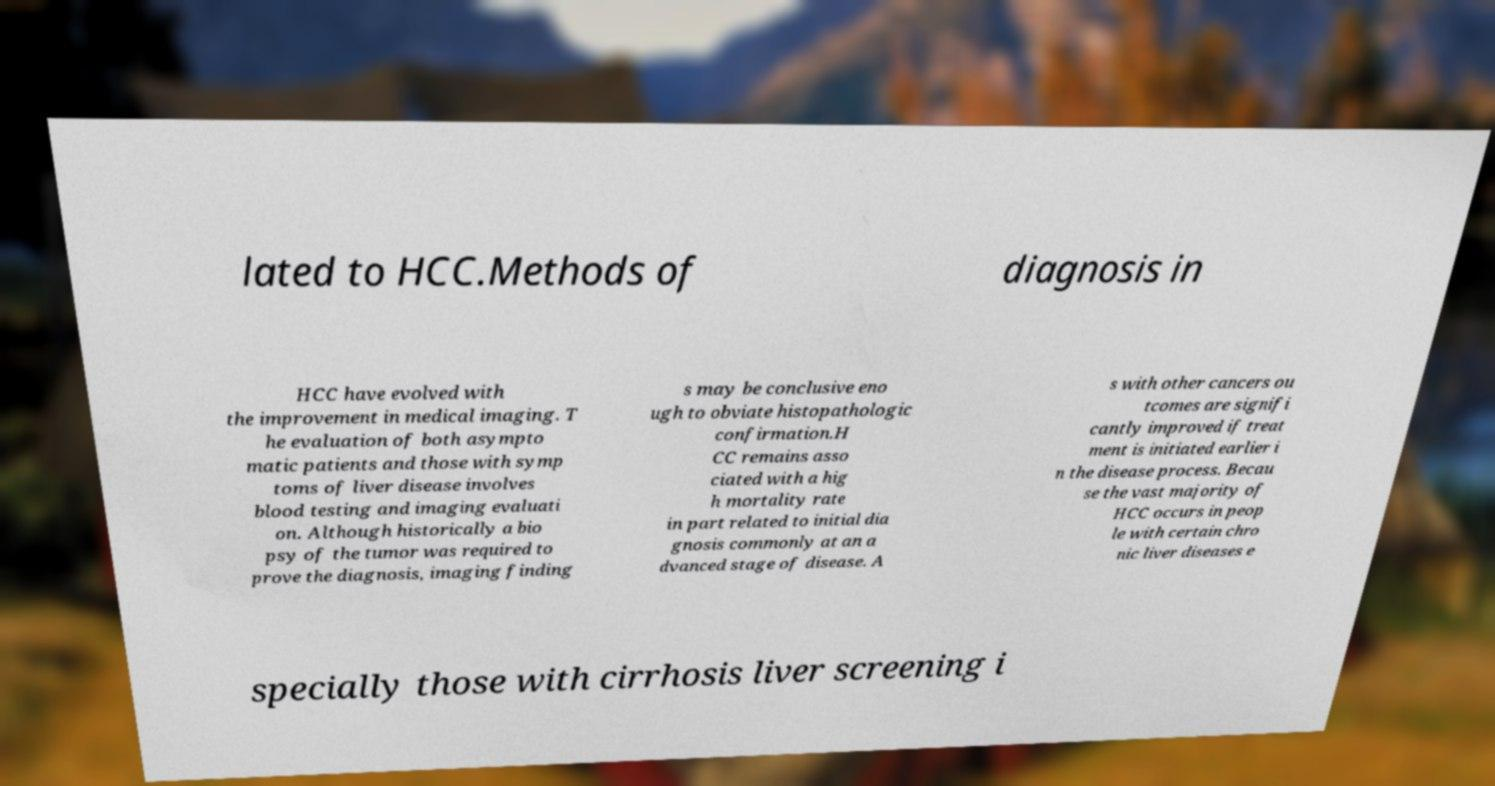Could you assist in decoding the text presented in this image and type it out clearly? lated to HCC.Methods of diagnosis in HCC have evolved with the improvement in medical imaging. T he evaluation of both asympto matic patients and those with symp toms of liver disease involves blood testing and imaging evaluati on. Although historically a bio psy of the tumor was required to prove the diagnosis, imaging finding s may be conclusive eno ugh to obviate histopathologic confirmation.H CC remains asso ciated with a hig h mortality rate in part related to initial dia gnosis commonly at an a dvanced stage of disease. A s with other cancers ou tcomes are signifi cantly improved if treat ment is initiated earlier i n the disease process. Becau se the vast majority of HCC occurs in peop le with certain chro nic liver diseases e specially those with cirrhosis liver screening i 